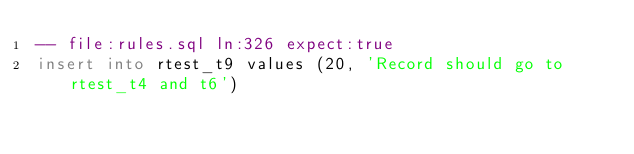Convert code to text. <code><loc_0><loc_0><loc_500><loc_500><_SQL_>-- file:rules.sql ln:326 expect:true
insert into rtest_t9 values (20, 'Record should go to rtest_t4 and t6')
</code> 